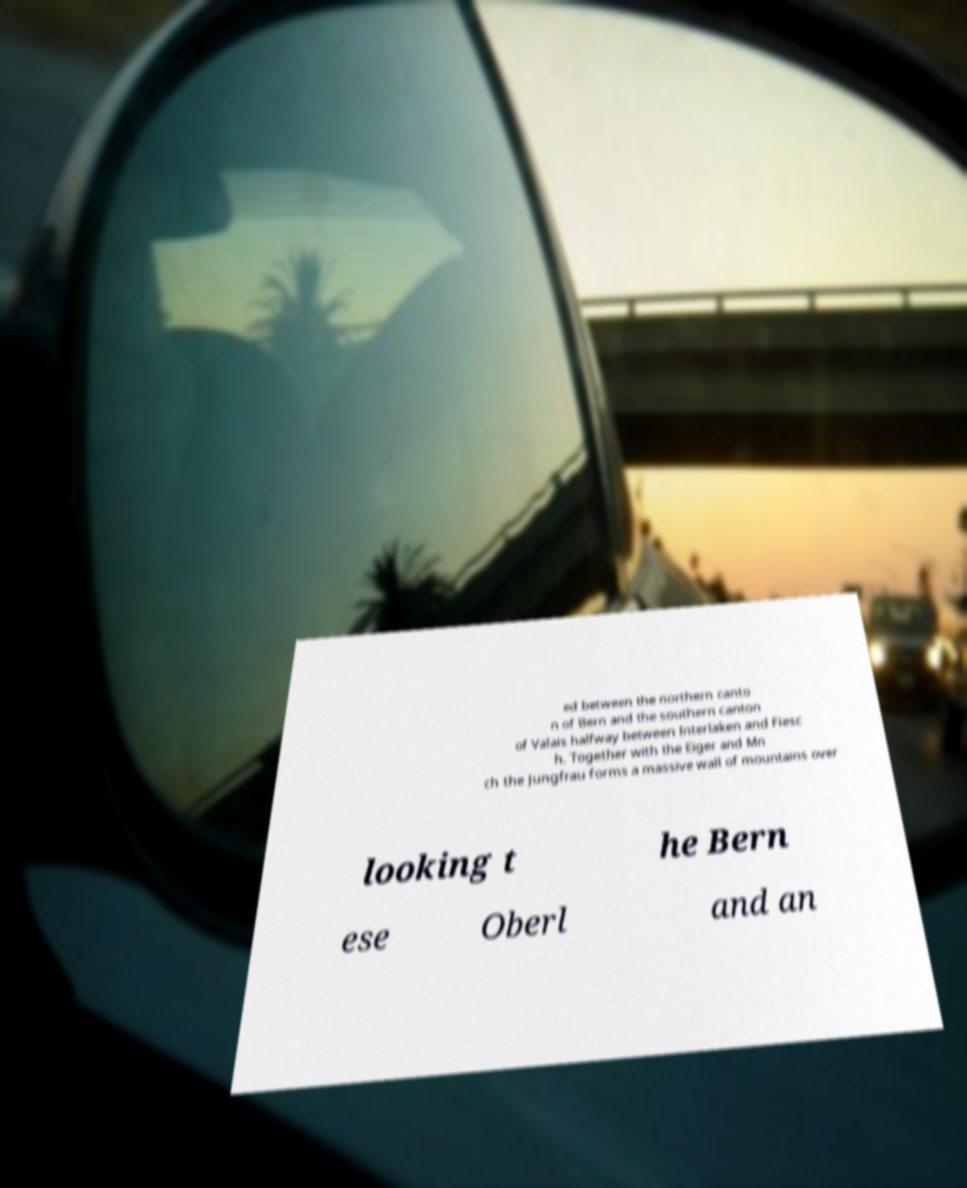What messages or text are displayed in this image? I need them in a readable, typed format. ed between the northern canto n of Bern and the southern canton of Valais halfway between Interlaken and Fiesc h. Together with the Eiger and Mn ch the Jungfrau forms a massive wall of mountains over looking t he Bern ese Oberl and an 